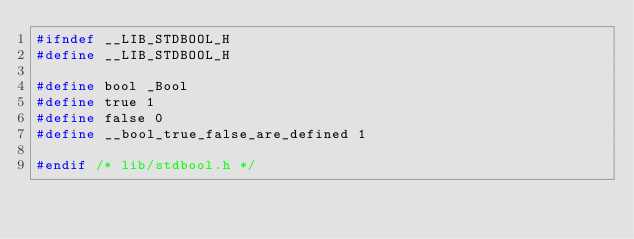<code> <loc_0><loc_0><loc_500><loc_500><_C_>#ifndef __LIB_STDBOOL_H
#define __LIB_STDBOOL_H

#define bool _Bool
#define true 1
#define false 0
#define __bool_true_false_are_defined 1

#endif /* lib/stdbool.h */
</code> 